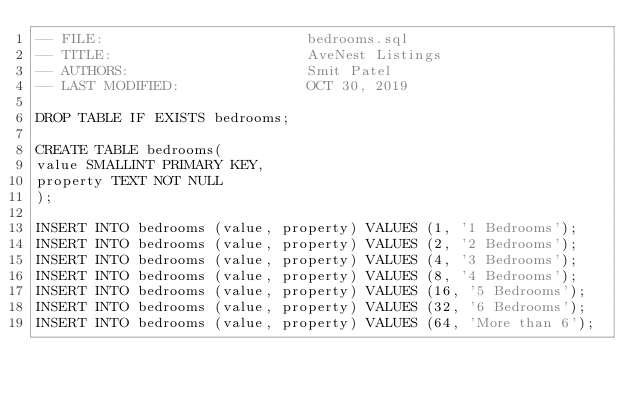Convert code to text. <code><loc_0><loc_0><loc_500><loc_500><_SQL_>-- FILE: 						bedrooms.sql
-- TITLE:						AveNest Listings
-- AUTHORS:						Smit Patel
-- LAST MODIFIED:		        OCT 30, 2019

DROP TABLE IF EXISTS bedrooms;

CREATE TABLE bedrooms(
value SMALLINT PRIMARY KEY,
property TEXT NOT NULL
);

INSERT INTO bedrooms (value, property) VALUES (1, '1 Bedrooms');
INSERT INTO bedrooms (value, property) VALUES (2, '2 Bedrooms');
INSERT INTO bedrooms (value, property) VALUES (4, '3 Bedrooms');
INSERT INTO bedrooms (value, property) VALUES (8, '4 Bedrooms');
INSERT INTO bedrooms (value, property) VALUES (16, '5 Bedrooms');
INSERT INTO bedrooms (value, property) VALUES (32, '6 Bedrooms');
INSERT INTO bedrooms (value, property) VALUES (64, 'More than 6');</code> 